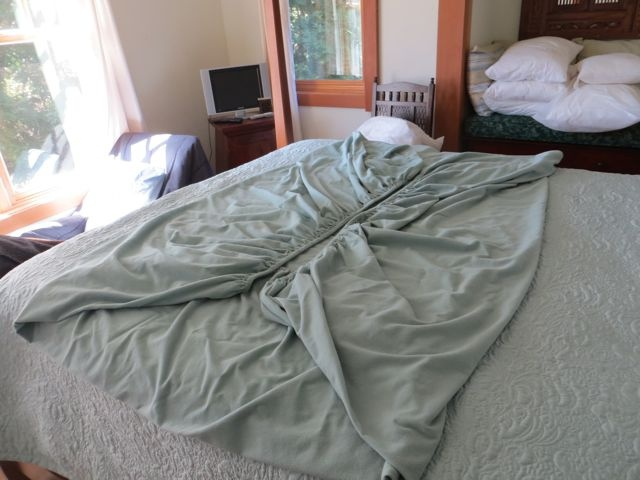Describe the objects in this image and their specific colors. I can see bed in darkgray and gray tones, tv in darkgray, black, and gray tones, chair in darkgray, gray, and black tones, and remote in darkgray, black, and gray tones in this image. 